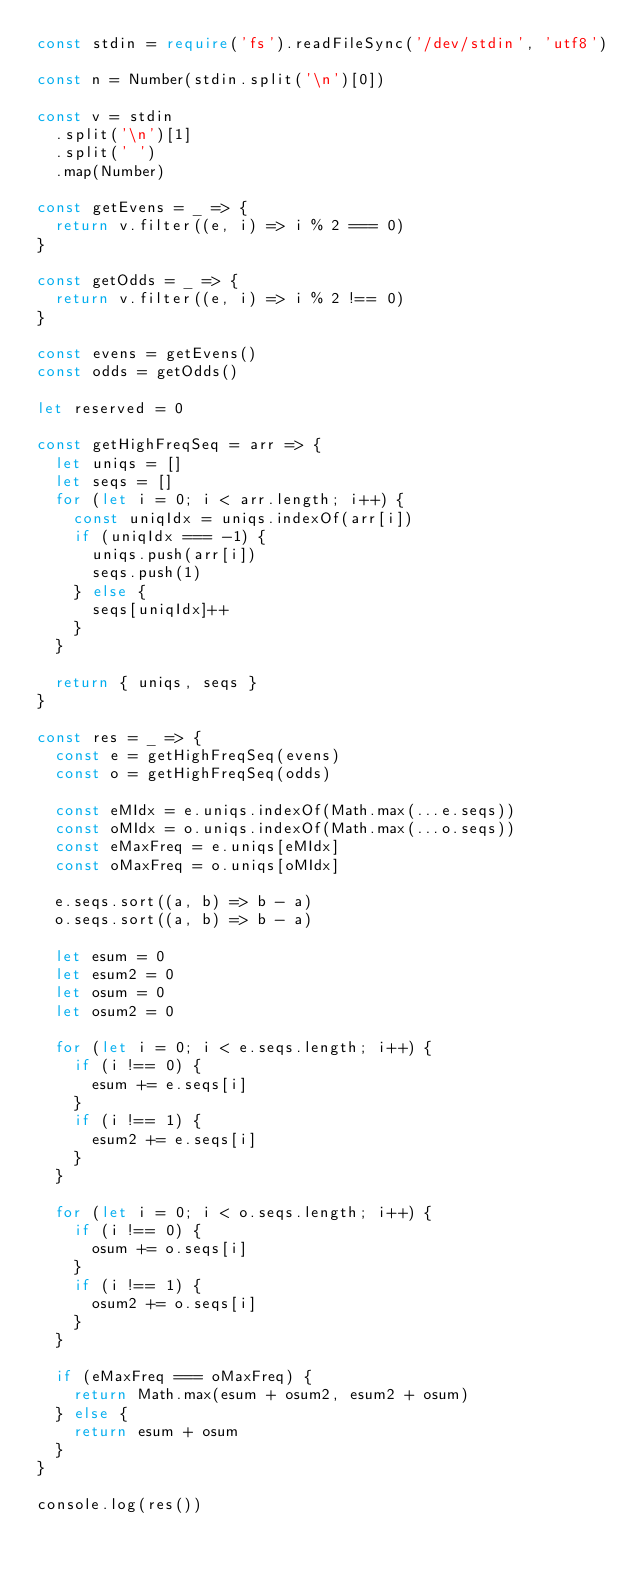Convert code to text. <code><loc_0><loc_0><loc_500><loc_500><_TypeScript_>const stdin = require('fs').readFileSync('/dev/stdin', 'utf8')

const n = Number(stdin.split('\n')[0])

const v = stdin
  .split('\n')[1]
  .split(' ')
  .map(Number)

const getEvens = _ => {
  return v.filter((e, i) => i % 2 === 0)
}

const getOdds = _ => {
  return v.filter((e, i) => i % 2 !== 0)
}

const evens = getEvens()
const odds = getOdds()

let reserved = 0

const getHighFreqSeq = arr => {
  let uniqs = []
  let seqs = []
  for (let i = 0; i < arr.length; i++) {
    const uniqIdx = uniqs.indexOf(arr[i])
    if (uniqIdx === -1) {
      uniqs.push(arr[i])
      seqs.push(1)
    } else {
      seqs[uniqIdx]++
    }
  }

  return { uniqs, seqs }
}

const res = _ => {
  const e = getHighFreqSeq(evens)
  const o = getHighFreqSeq(odds)

  const eMIdx = e.uniqs.indexOf(Math.max(...e.seqs))
  const oMIdx = o.uniqs.indexOf(Math.max(...o.seqs))
  const eMaxFreq = e.uniqs[eMIdx]
  const oMaxFreq = o.uniqs[oMIdx]

  e.seqs.sort((a, b) => b - a)
  o.seqs.sort((a, b) => b - a)

  let esum = 0
  let esum2 = 0
  let osum = 0
  let osum2 = 0

  for (let i = 0; i < e.seqs.length; i++) {
    if (i !== 0) {
      esum += e.seqs[i]
    }
    if (i !== 1) {
      esum2 += e.seqs[i]
    }
  }

  for (let i = 0; i < o.seqs.length; i++) {
    if (i !== 0) {
      osum += o.seqs[i]
    }
    if (i !== 1) {
      osum2 += o.seqs[i]
    }
  }

  if (eMaxFreq === oMaxFreq) {
    return Math.max(esum + osum2, esum2 + osum)
  } else {
    return esum + osum
  }
}

console.log(res())
</code> 